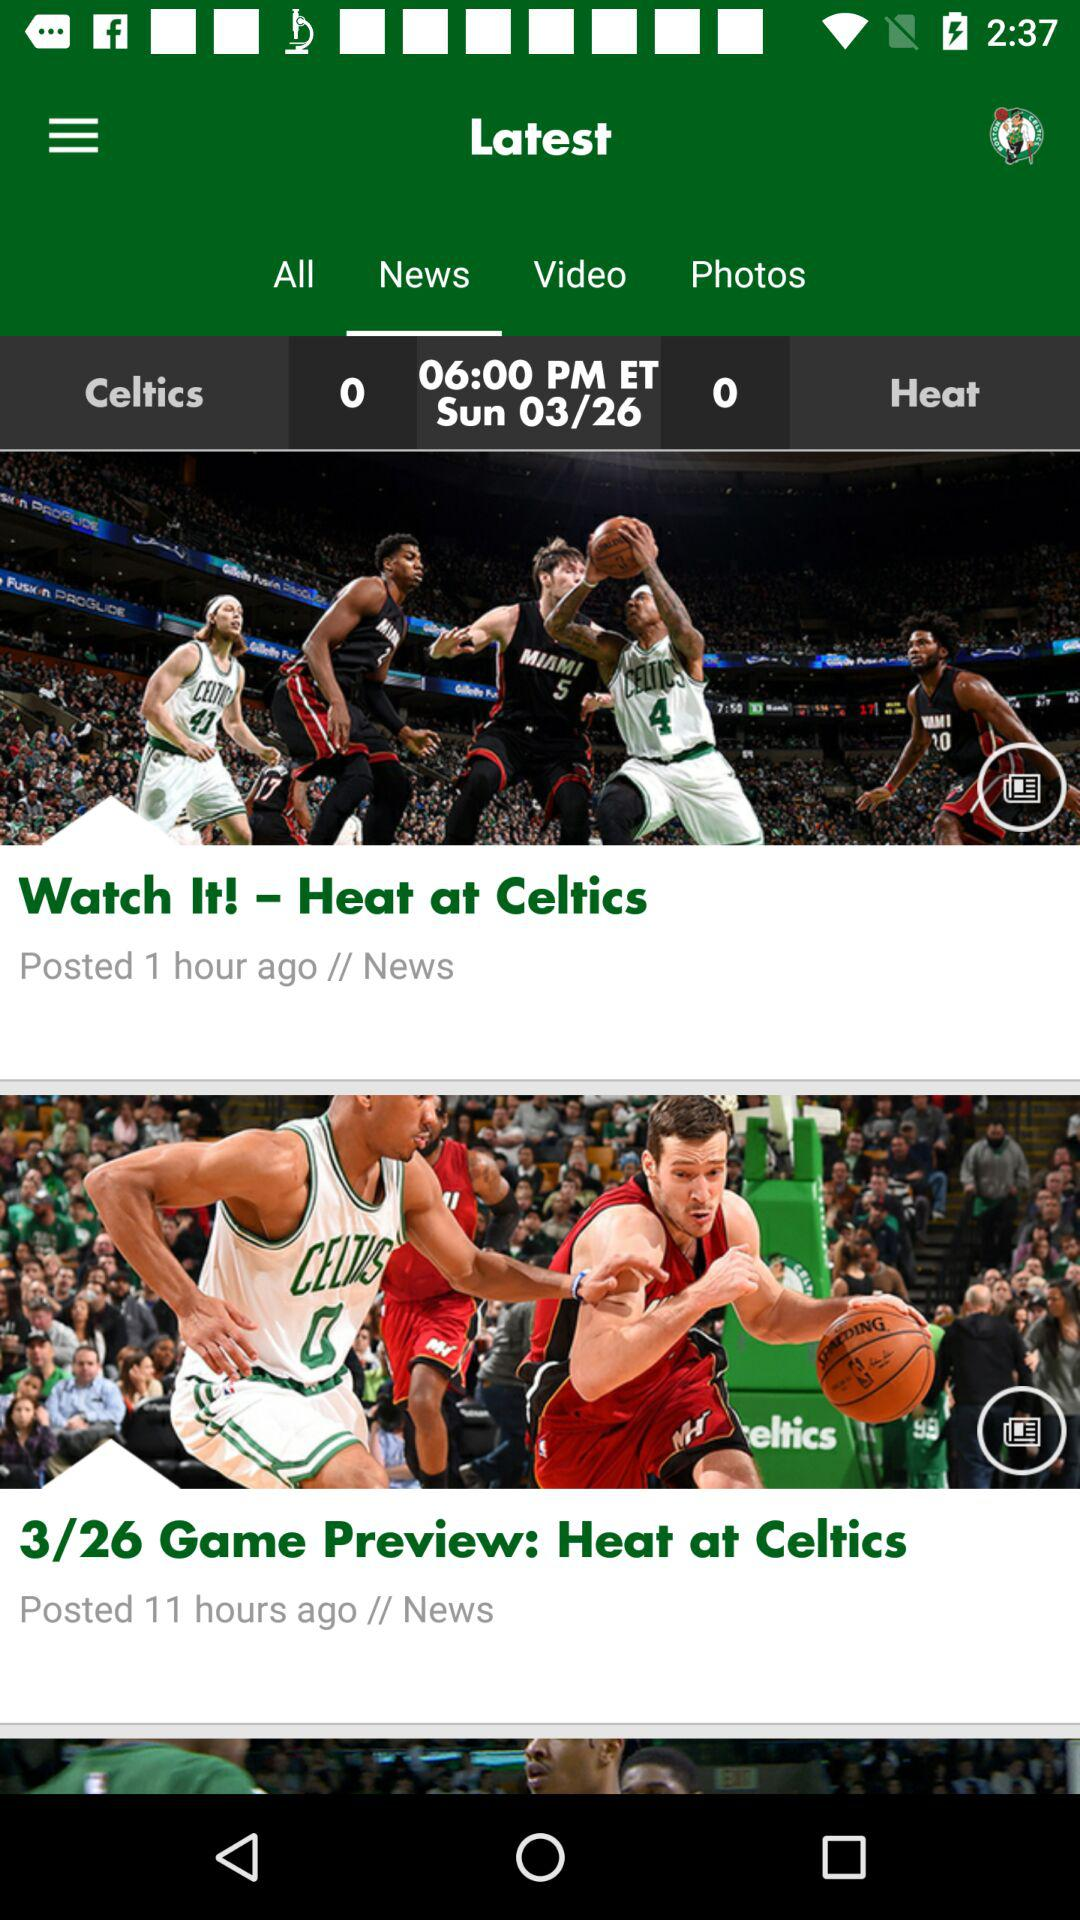What is the selected tab? The selected tab is "News". 